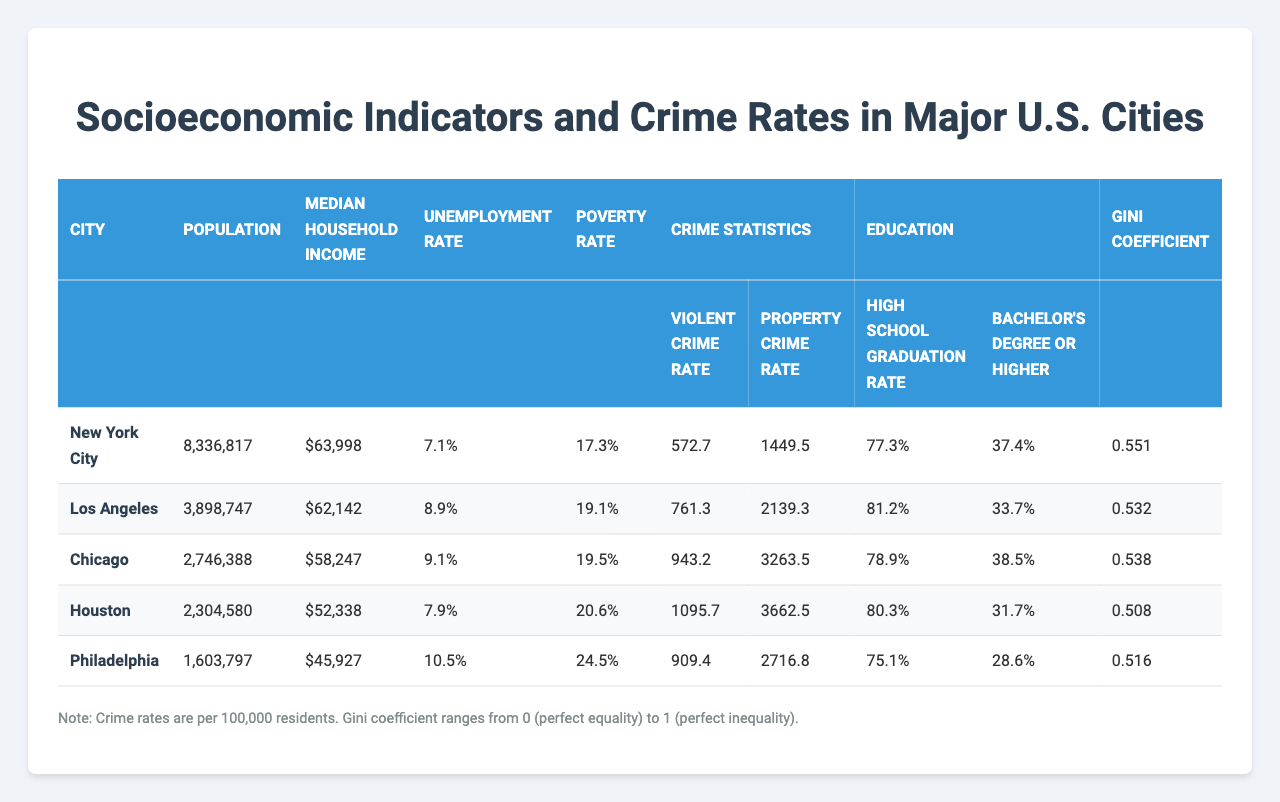What is the median household income of Chicago? The table shows the median household income for each city. For Chicago, it is listed as $58,247.
Answer: $58,247 Which city has the highest violent crime rate? By comparing the violent crime rates in the table, Houston has the highest rate at 1,095.7 per 100,000 residents.
Answer: Houston What is the average unemployment rate across the five cities? To find the average of the unemployment rates, I sum the rates (7.1 + 8.9 + 9.1 + 7.9 + 10.5 = 43.5) and then divide by the number of cities (5). The average unemployment rate is 43.5 / 5 = 8.7%.
Answer: 8.7% Is the high school graduation rate in Los Angeles greater than that in Philadelphia? The graduation rate for Los Angeles is 81.2%, while for Philadelphia it is 75.1%. Since 81.2% is greater than 75.1%, the statement is true.
Answer: Yes Which city has the lowest poverty rate, and what is that rate? The poverty rates for each city are 17.3%, 19.1%, 19.5%, 20.6%, and 24.5%. The lowest poverty rate is 17.3%, which belongs to New York City.
Answer: New York City, 17.3% What is the difference in property crime rates between Chicago and Los Angeles? Chicago's property crime rate is 3,263.5, and Los Angeles's is 2,139.3. The difference is calculated as 3,263.5 - 2,139.3 = 1,124.2.
Answer: 1,124.2 Does higher median household income correlate with lower poverty rates among these cities? A quick review shows that New York City, with a median household income of $63,998, has a poverty rate of 17.3%. In contrast, Houston with a lower income of $52,338 has a higher poverty rate of 20.6%. This suggests a negative correlation in some cases, but a detailed analysis may be necessary for clearer insights.
Answer: Not necessarily What city has both the highest education levels (bachelor's degree or higher) and the lowest Gini coefficient? Chicago has the highest percentage of residents with a bachelor's degree or higher at 38.5%, and also has the lowest Gini coefficient at 0.538 among the given cities.
Answer: Chicago If we look at cities with violent crime rates above 900, what are their median incomes? The cities with violent crime rates above 900 are Chicago (1,095.7), Houston (943.2), and Philadelphia (909.4). Their corresponding median incomes are $58,247 (Chicago), $52,338 (Houston), and $45,927 (Philadelphia).
Answer: $58,247, $52,338, $45,927 What is the ratio of high school graduation rates between Houston and Philadelphia? Houston's high school graduation rate is 80.3%, and Philadelphia's is 75.1%. To find the ratio, you divide 80.3% by 75.1%, resulting in approximately 1.068.
Answer: 1.068 